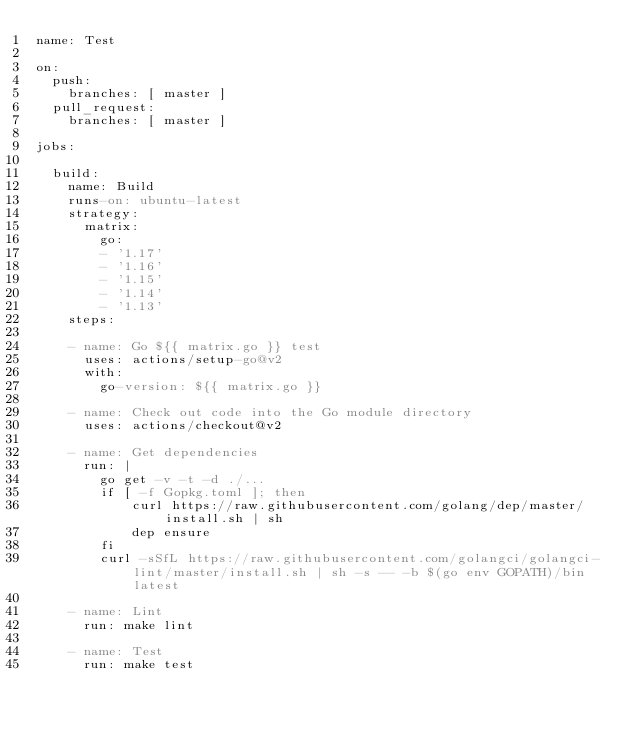Convert code to text. <code><loc_0><loc_0><loc_500><loc_500><_YAML_>name: Test

on:
  push:
    branches: [ master ]
  pull_request:
    branches: [ master ]

jobs:

  build:
    name: Build
    runs-on: ubuntu-latest
    strategy:
      matrix:
        go:
        - '1.17'
        - '1.16'
        - '1.15'
        - '1.14'
        - '1.13'
    steps:

    - name: Go ${{ matrix.go }} test 
      uses: actions/setup-go@v2
      with:
        go-version: ${{ matrix.go }}

    - name: Check out code into the Go module directory
      uses: actions/checkout@v2

    - name: Get dependencies
      run: |
        go get -v -t -d ./...
        if [ -f Gopkg.toml ]; then
            curl https://raw.githubusercontent.com/golang/dep/master/install.sh | sh
            dep ensure
        fi
        curl -sSfL https://raw.githubusercontent.com/golangci/golangci-lint/master/install.sh | sh -s -- -b $(go env GOPATH)/bin latest

    - name: Lint
      run: make lint

    - name: Test
      run: make test

</code> 